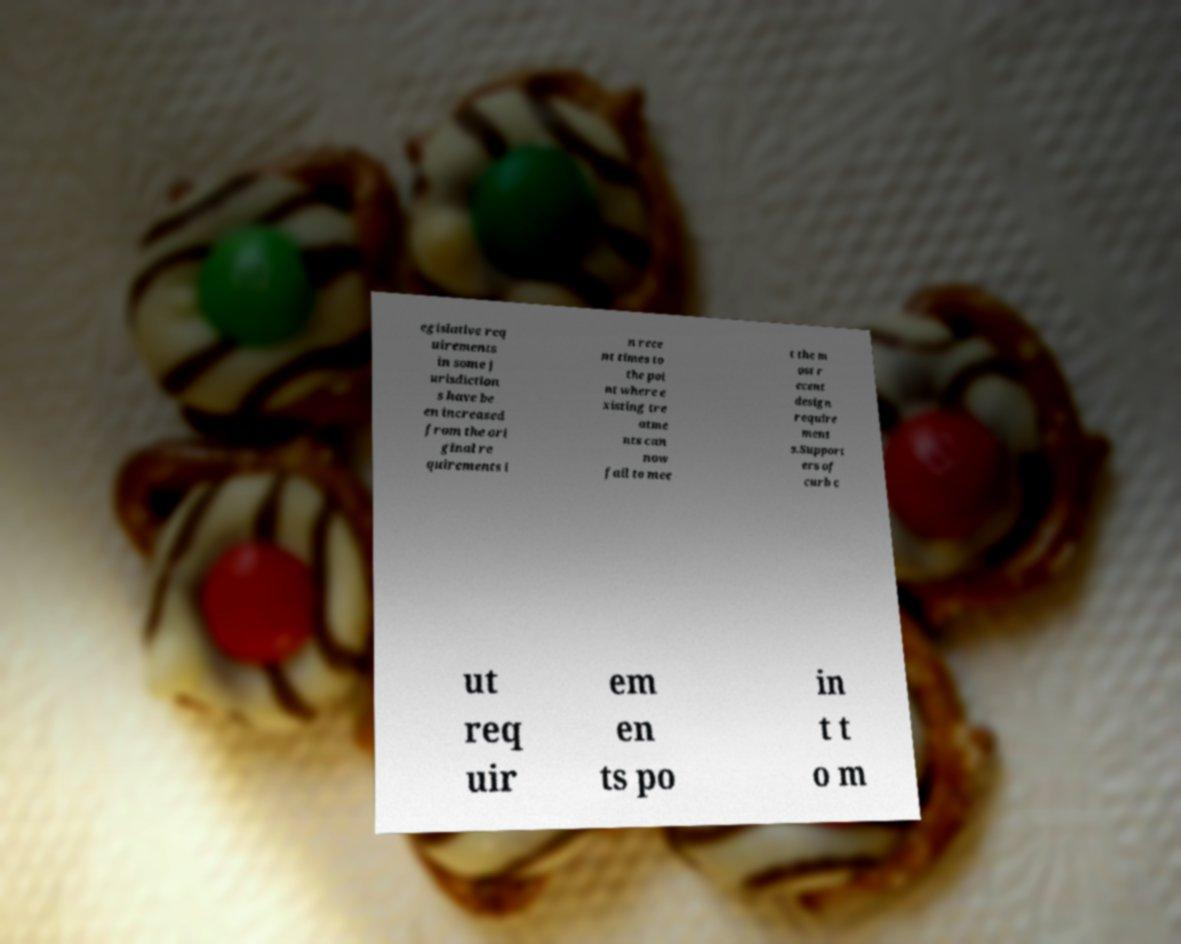Please identify and transcribe the text found in this image. egislative req uirements in some j urisdiction s have be en increased from the ori ginal re quirements i n rece nt times to the poi nt where e xisting tre atme nts can now fail to mee t the m ost r ecent design require ment s.Support ers of curb c ut req uir em en ts po in t t o m 